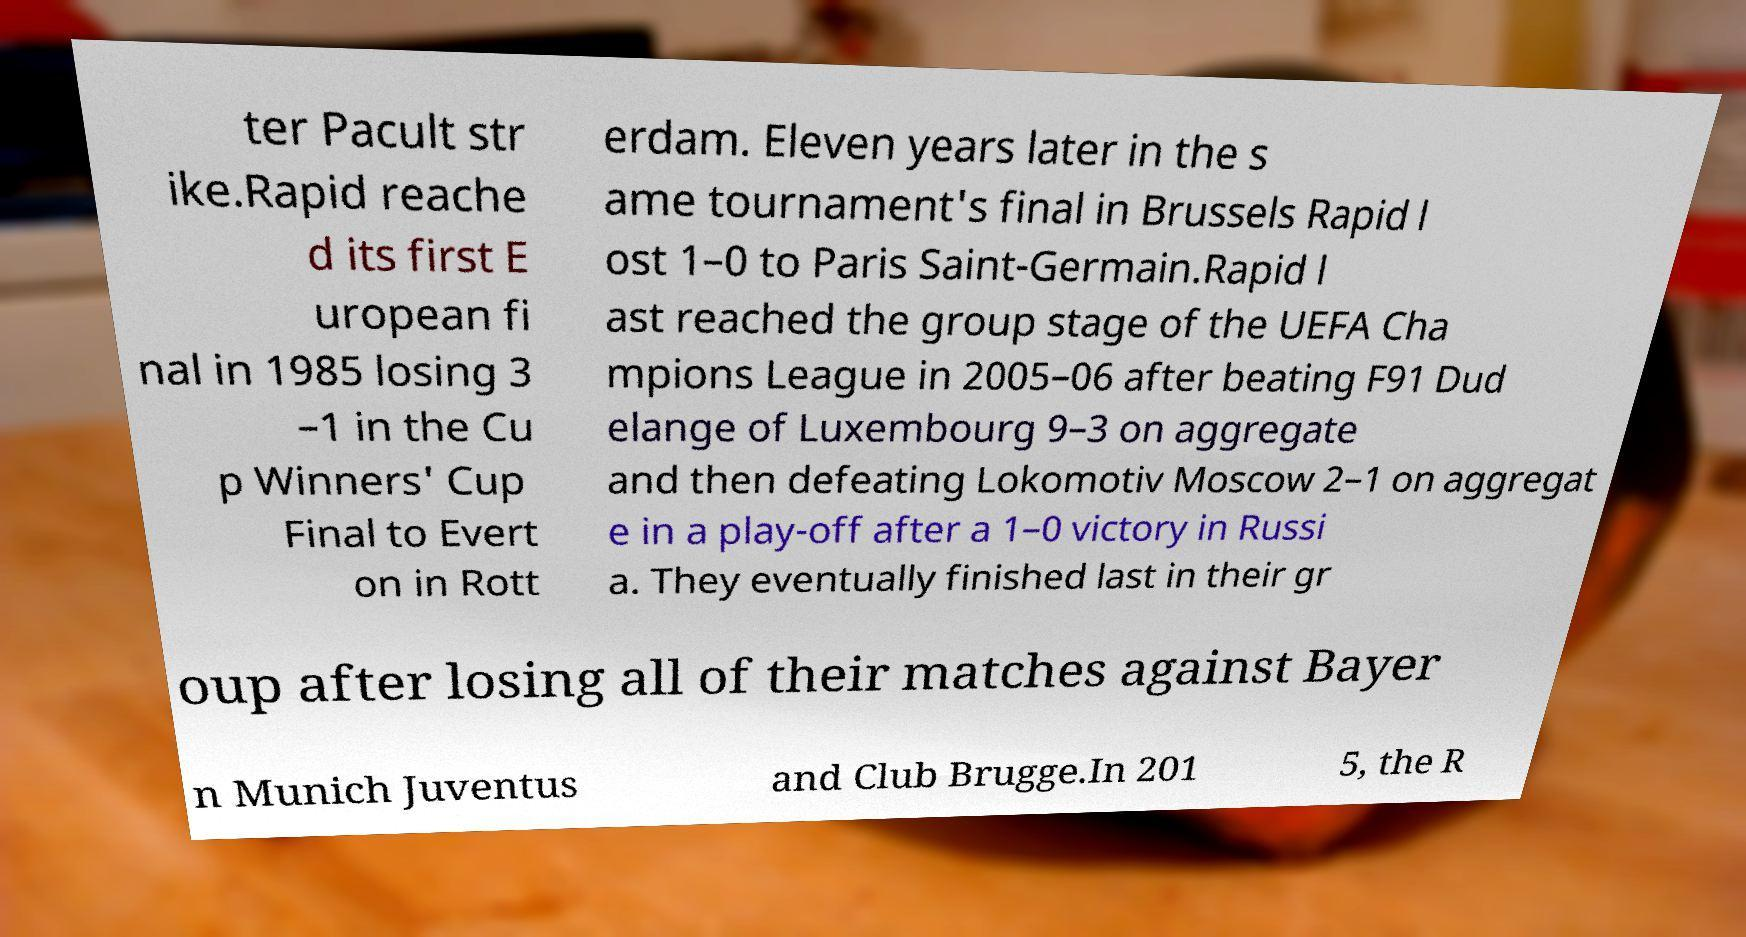Can you accurately transcribe the text from the provided image for me? ter Pacult str ike.Rapid reache d its first E uropean fi nal in 1985 losing 3 –1 in the Cu p Winners' Cup Final to Evert on in Rott erdam. Eleven years later in the s ame tournament's final in Brussels Rapid l ost 1–0 to Paris Saint-Germain.Rapid l ast reached the group stage of the UEFA Cha mpions League in 2005–06 after beating F91 Dud elange of Luxembourg 9–3 on aggregate and then defeating Lokomotiv Moscow 2–1 on aggregat e in a play-off after a 1–0 victory in Russi a. They eventually finished last in their gr oup after losing all of their matches against Bayer n Munich Juventus and Club Brugge.In 201 5, the R 